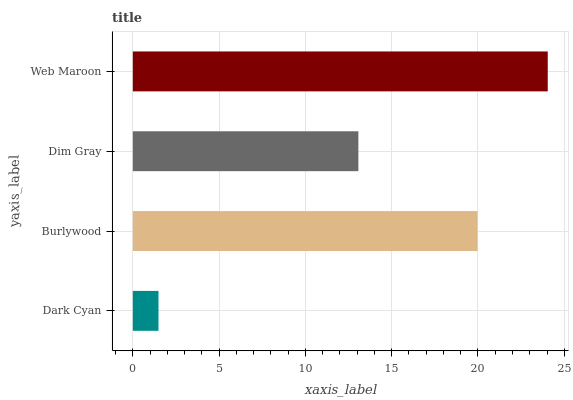Is Dark Cyan the minimum?
Answer yes or no. Yes. Is Web Maroon the maximum?
Answer yes or no. Yes. Is Burlywood the minimum?
Answer yes or no. No. Is Burlywood the maximum?
Answer yes or no. No. Is Burlywood greater than Dark Cyan?
Answer yes or no. Yes. Is Dark Cyan less than Burlywood?
Answer yes or no. Yes. Is Dark Cyan greater than Burlywood?
Answer yes or no. No. Is Burlywood less than Dark Cyan?
Answer yes or no. No. Is Burlywood the high median?
Answer yes or no. Yes. Is Dim Gray the low median?
Answer yes or no. Yes. Is Dark Cyan the high median?
Answer yes or no. No. Is Web Maroon the low median?
Answer yes or no. No. 